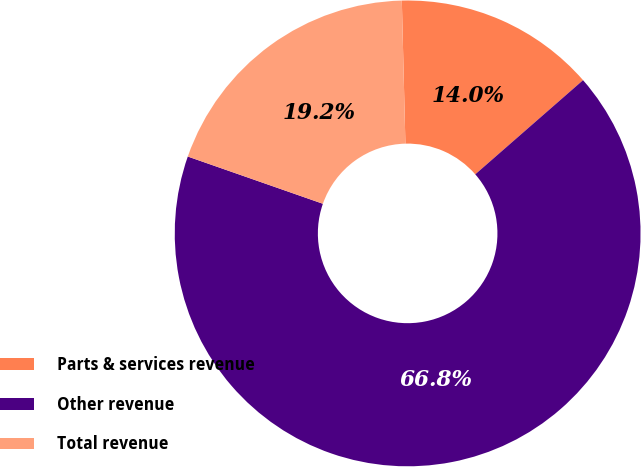Convert chart to OTSL. <chart><loc_0><loc_0><loc_500><loc_500><pie_chart><fcel>Parts & services revenue<fcel>Other revenue<fcel>Total revenue<nl><fcel>13.97%<fcel>66.78%<fcel>19.25%<nl></chart> 